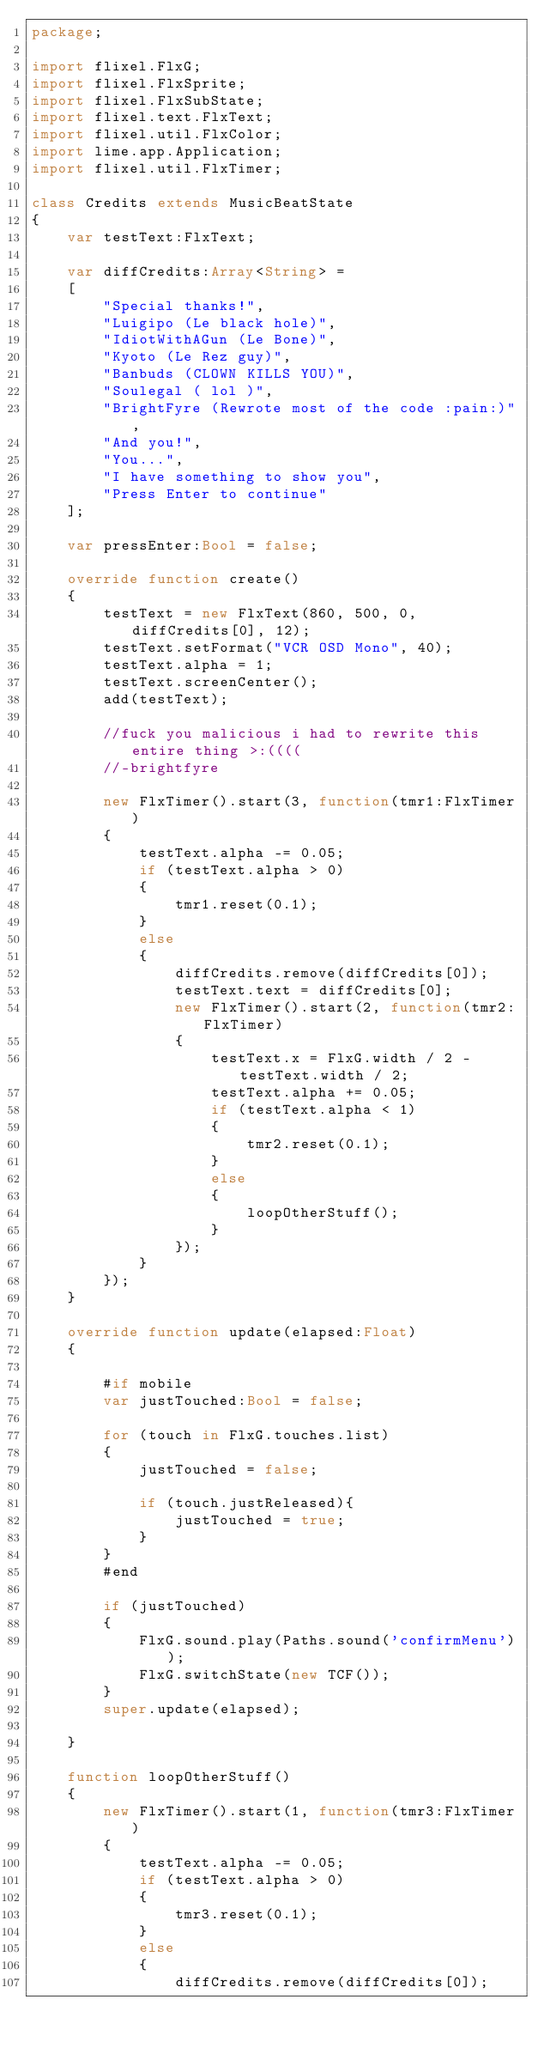Convert code to text. <code><loc_0><loc_0><loc_500><loc_500><_Haxe_>package;

import flixel.FlxG;
import flixel.FlxSprite;
import flixel.FlxSubState;
import flixel.text.FlxText;
import flixel.util.FlxColor;
import lime.app.Application;
import flixel.util.FlxTimer;

class Credits extends MusicBeatState
{
	var testText:FlxText;

	var diffCredits:Array<String> = 
	[
		"Special thanks!",
		"Luigipo (Le black hole)",
		"IdiotWithAGun (Le Bone)",
		"Kyoto (Le Rez guy)",
		"Banbuds (CLOWN KILLS YOU)",
		"Soulegal ( lol )",
		"BrightFyre (Rewrote most of the code :pain:)",
		"And you!",
		"You...",
		"I have something to show you",
		"Press Enter to continue"
	];

	var pressEnter:Bool = false;

	override function create()
	{
		testText = new FlxText(860, 500, 0, diffCredits[0], 12);
		testText.setFormat("VCR OSD Mono", 40);	
		testText.alpha = 1;
		testText.screenCenter();
		add(testText);

		//fuck you malicious i had to rewrite this entire thing >:((((
		//-brightfyre

		new FlxTimer().start(3, function(tmr1:FlxTimer)
		{	
			testText.alpha -= 0.05;
			if (testText.alpha > 0)
			{
				tmr1.reset(0.1);
			}
			else
			{
				diffCredits.remove(diffCredits[0]);
				testText.text = diffCredits[0];
				new FlxTimer().start(2, function(tmr2:FlxTimer)
				{
					testText.x = FlxG.width / 2 - testText.width / 2;
					testText.alpha += 0.05;
					if (testText.alpha < 1)
					{
						tmr2.reset(0.1);
					}
					else
					{
						loopOtherStuff();
					}
				});	
			}
		});
	}

	override function update(elapsed:Float)
	{
		
		#if mobile
		var justTouched:Bool = false;

		for (touch in FlxG.touches.list)
		{
			justTouched = false;

			if (touch.justReleased){
				justTouched = true;
			}
		}
		#end

		if (justTouched)
		{
			FlxG.sound.play(Paths.sound('confirmMenu'));
			FlxG.switchState(new TCF());
		}
		super.update(elapsed);

	}

	function loopOtherStuff()
	{
		new FlxTimer().start(1, function(tmr3:FlxTimer)
		{	
			testText.alpha -= 0.05;
			if (testText.alpha > 0)
			{
				tmr3.reset(0.1);
			}
			else
			{
				diffCredits.remove(diffCredits[0]);</code> 